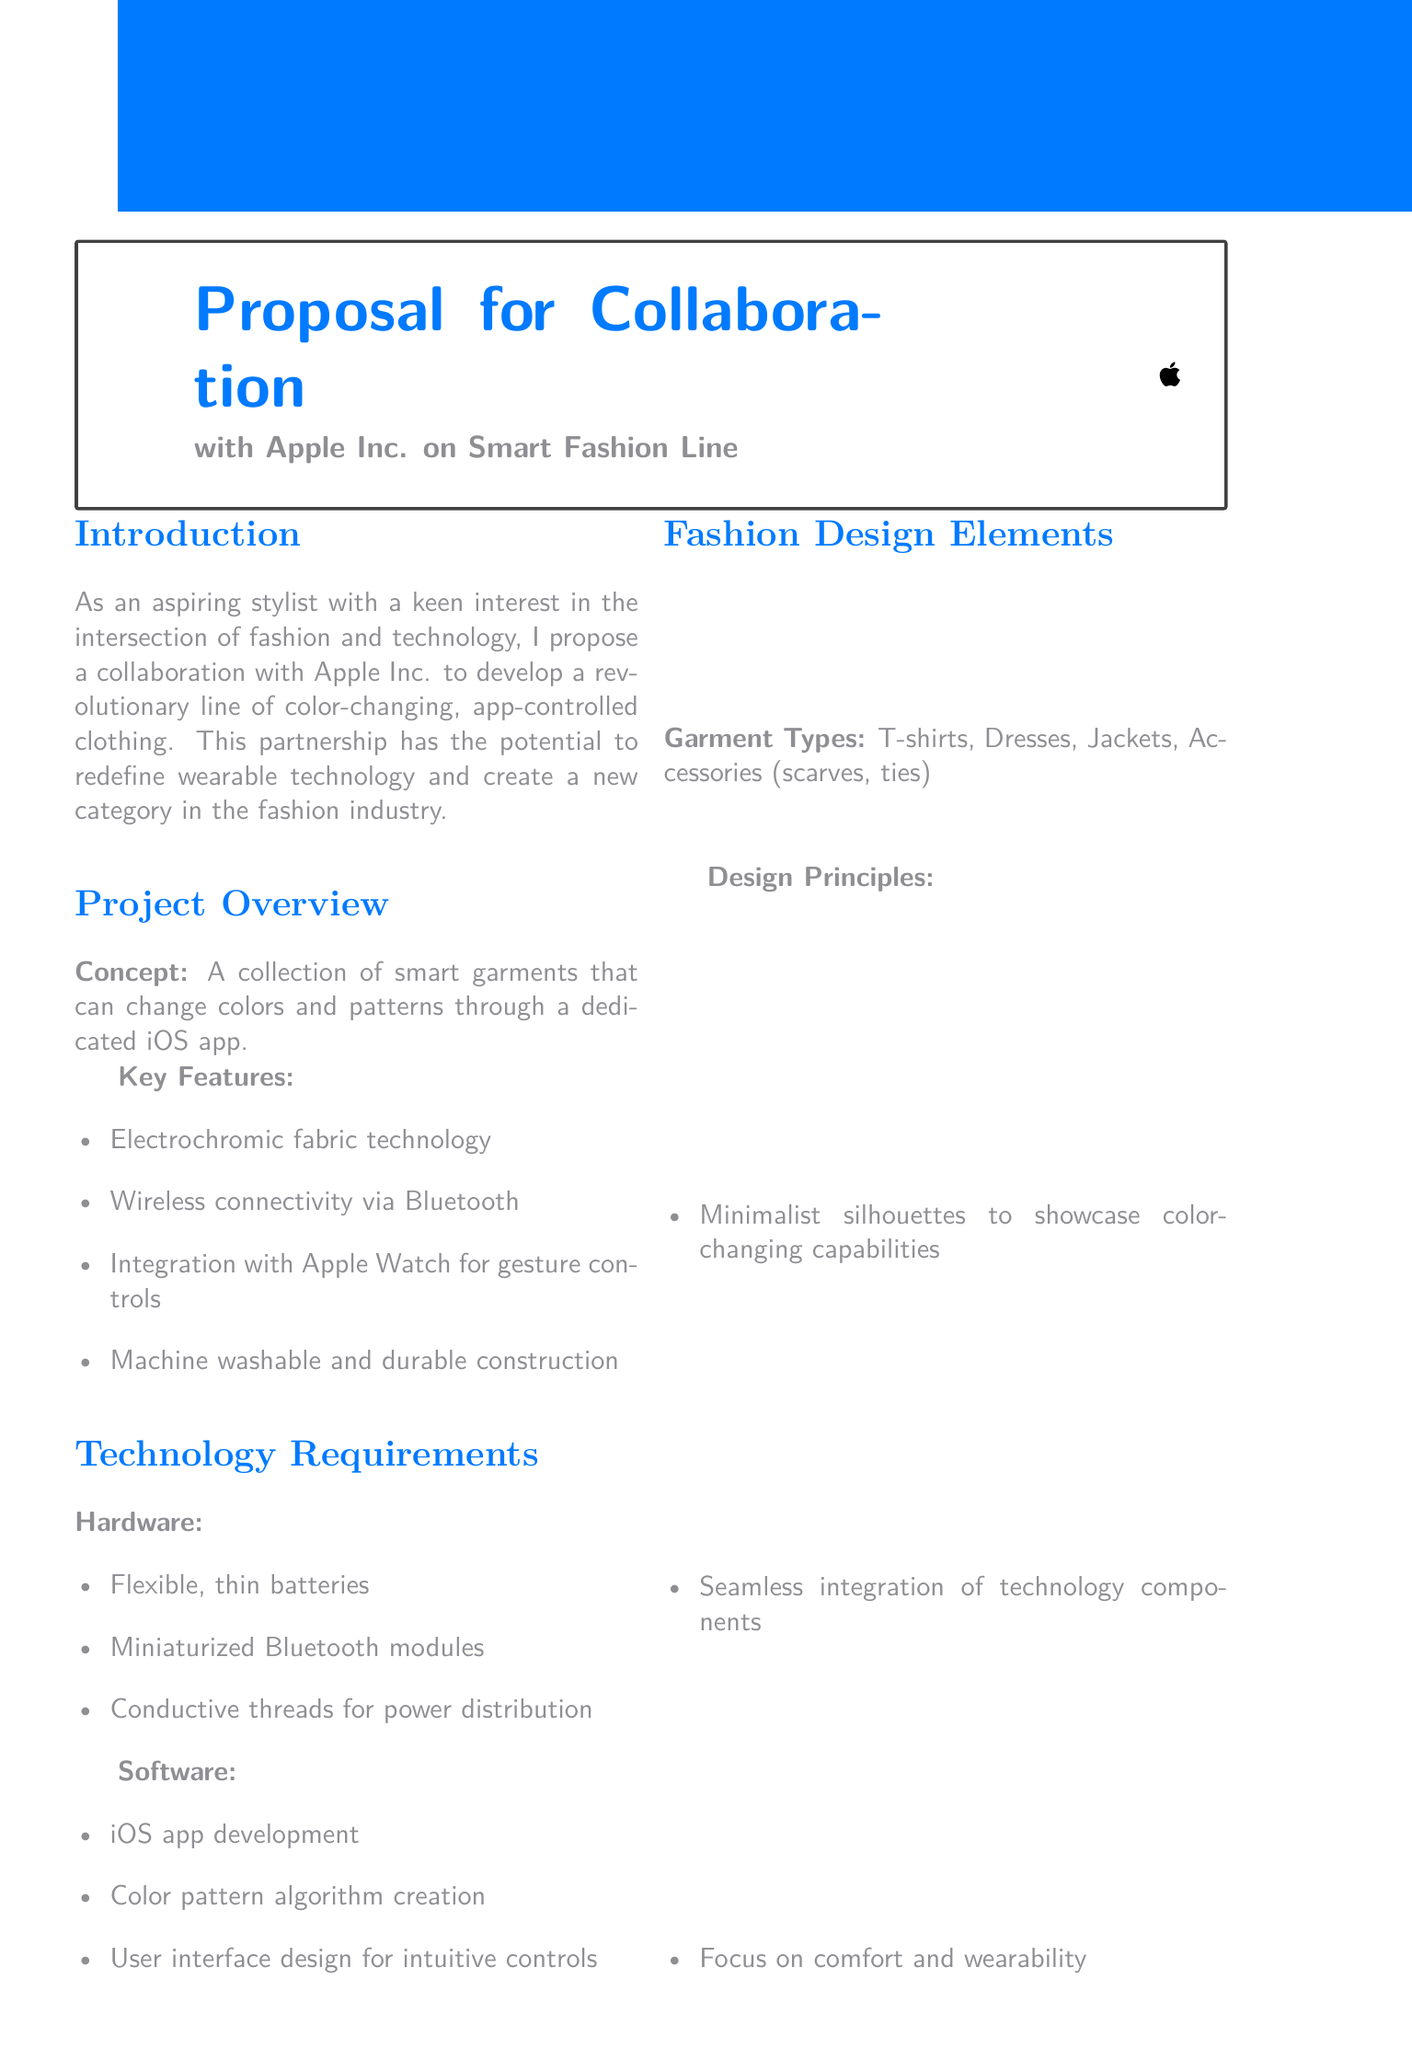what is the proposed partnership? The proposed partnership is with Apple Inc. to develop a line of color-changing, app-controlled clothing.
Answer: Apple Inc what is the estimated market size by 2025? The estimated market size is provided entirely in the document as a projection for the clothing segment.
Answer: $5 billion what technology will the clothing use for wireless connectivity? The technology for wireless connectivity is specified in the document under key features.
Answer: Bluetooth how long will the first phase of development take? The document specifies the duration of each development phase, particularly the first phase for research and development.
Answer: 6 months what is a key competitive advantage mentioned? The competitive advantage highlights the uniqueness of the new product in the market.
Answer: First-mover in the app-controlled, color-changing clothing segment what type of garments are included in the proposal? The document lists various garment types that will be included in the smart fashion line.
Answer: T-shirts, Dresses, Jackets, Accessories (scarves, ties) which technology component is meant for gesture controls? The technology component that integrates with gestures is specifically mentioned for the clothing line.
Answer: Apple Watch what is the budget for marketing and promotion? The budget estimates provided in the document outline costs for different areas, including marketing.
Answer: $5 million 